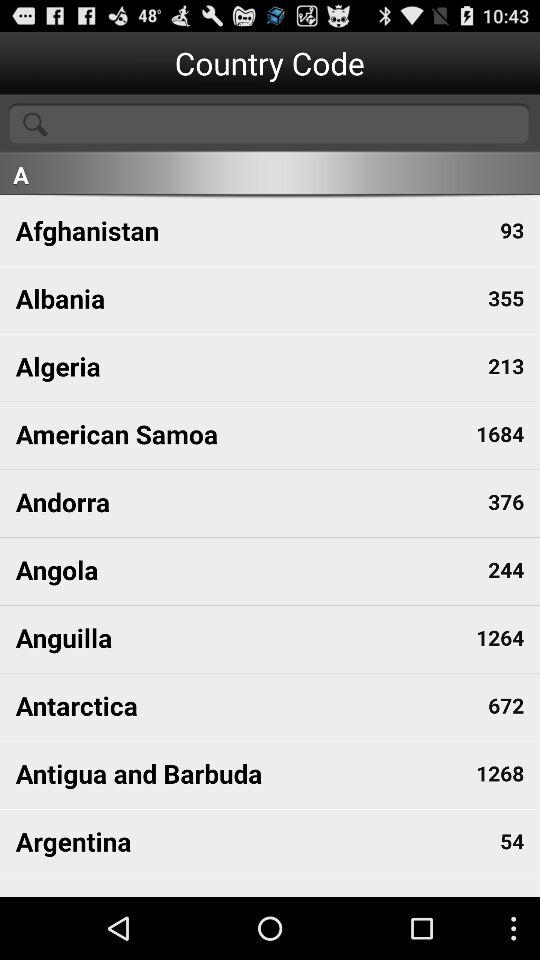What is the country code of Angola? The country code of Angola is 244. 